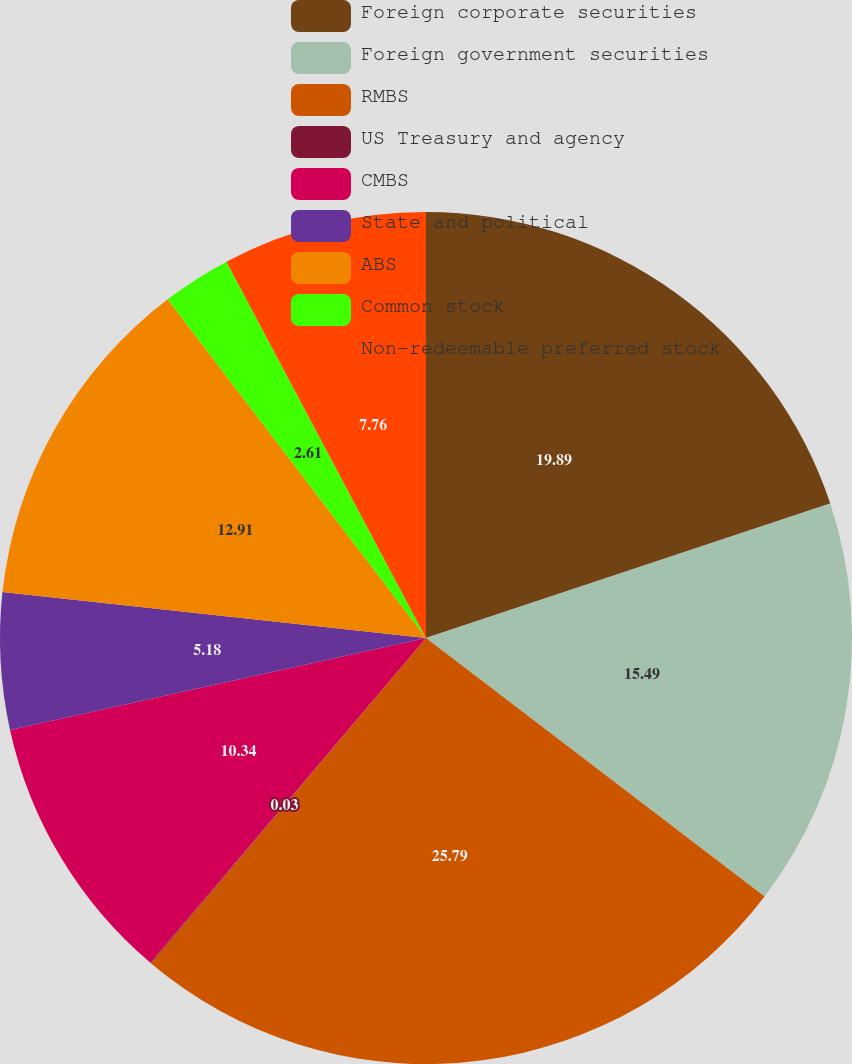Convert chart. <chart><loc_0><loc_0><loc_500><loc_500><pie_chart><fcel>Foreign corporate securities<fcel>Foreign government securities<fcel>RMBS<fcel>US Treasury and agency<fcel>CMBS<fcel>State and political<fcel>ABS<fcel>Common stock<fcel>Non-redeemable preferred stock<nl><fcel>19.89%<fcel>15.49%<fcel>25.79%<fcel>0.03%<fcel>10.34%<fcel>5.18%<fcel>12.91%<fcel>2.61%<fcel>7.76%<nl></chart> 